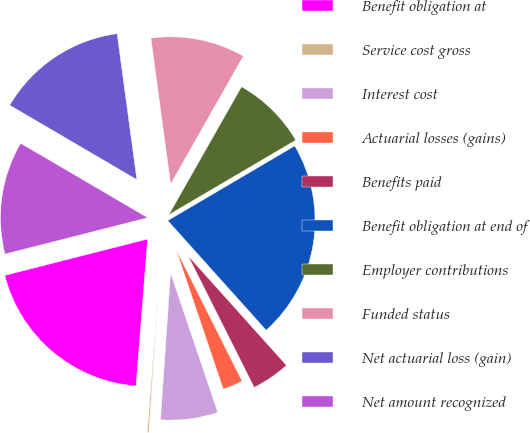Convert chart to OTSL. <chart><loc_0><loc_0><loc_500><loc_500><pie_chart><fcel>Benefit obligation at<fcel>Service cost gross<fcel>Interest cost<fcel>Actuarial losses (gains)<fcel>Benefits paid<fcel>Benefit obligation at end of<fcel>Employer contributions<fcel>Funded status<fcel>Net actuarial loss (gain)<fcel>Net amount recognized<nl><fcel>19.78%<fcel>0.17%<fcel>6.28%<fcel>2.21%<fcel>4.24%<fcel>21.82%<fcel>8.32%<fcel>10.36%<fcel>14.43%<fcel>12.4%<nl></chart> 